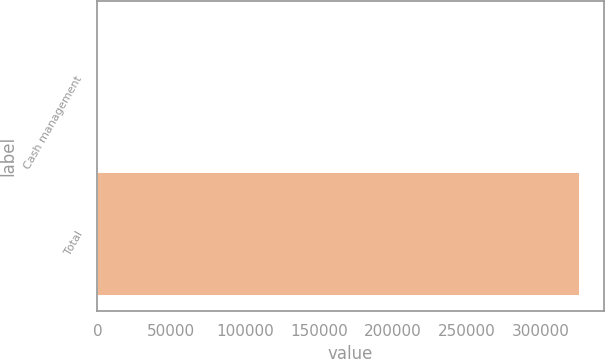Convert chart. <chart><loc_0><loc_0><loc_500><loc_500><bar_chart><fcel>Cash management<fcel>Total<nl><fcel>430<fcel>326364<nl></chart> 